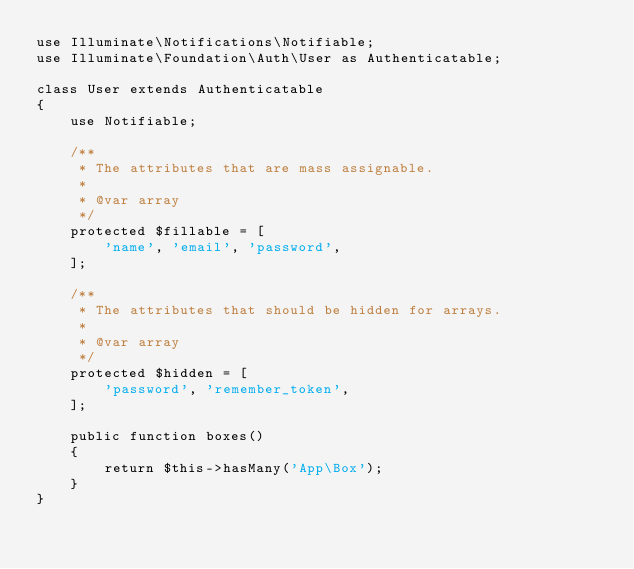<code> <loc_0><loc_0><loc_500><loc_500><_PHP_>use Illuminate\Notifications\Notifiable;
use Illuminate\Foundation\Auth\User as Authenticatable;

class User extends Authenticatable
{
    use Notifiable;

    /**
     * The attributes that are mass assignable.
     *
     * @var array
     */
    protected $fillable = [
        'name', 'email', 'password',
    ];

    /**
     * The attributes that should be hidden for arrays.
     *
     * @var array
     */
    protected $hidden = [
        'password', 'remember_token',
    ];

    public function boxes()
    {
        return $this->hasMany('App\Box');
    }
}
</code> 